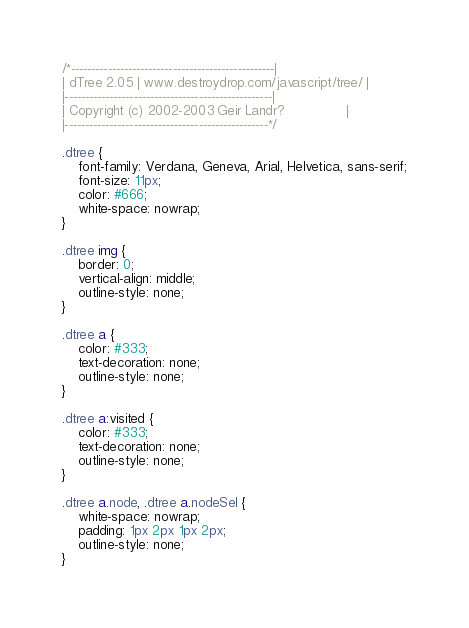<code> <loc_0><loc_0><loc_500><loc_500><_CSS_>/*--------------------------------------------------|
| dTree 2.05 | www.destroydrop.com/javascript/tree/ |
|---------------------------------------------------|
| Copyright (c) 2002-2003 Geir Landr?               |
|--------------------------------------------------*/

.dtree {
    font-family: Verdana, Geneva, Arial, Helvetica, sans-serif;
    font-size: 11px;
    color: #666;
    white-space: nowrap;
}

.dtree img {
    border: 0;
    vertical-align: middle;
    outline-style: none;
}

.dtree a {
    color: #333;
    text-decoration: none;
    outline-style: none;
}

.dtree a:visited {
    color: #333;
    text-decoration: none;
    outline-style: none;
}

.dtree a.node, .dtree a.nodeSel {
    white-space: nowrap;
    padding: 1px 2px 1px 2px;
    outline-style: none;
}
</code> 